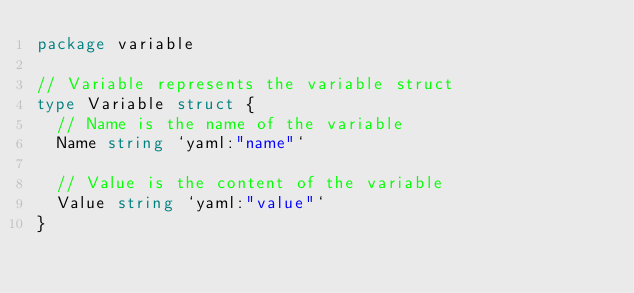<code> <loc_0><loc_0><loc_500><loc_500><_Go_>package variable

// Variable represents the variable struct
type Variable struct {
	// Name is the name of the variable
	Name string `yaml:"name"`

	// Value is the content of the variable
	Value string `yaml:"value"`
}
</code> 